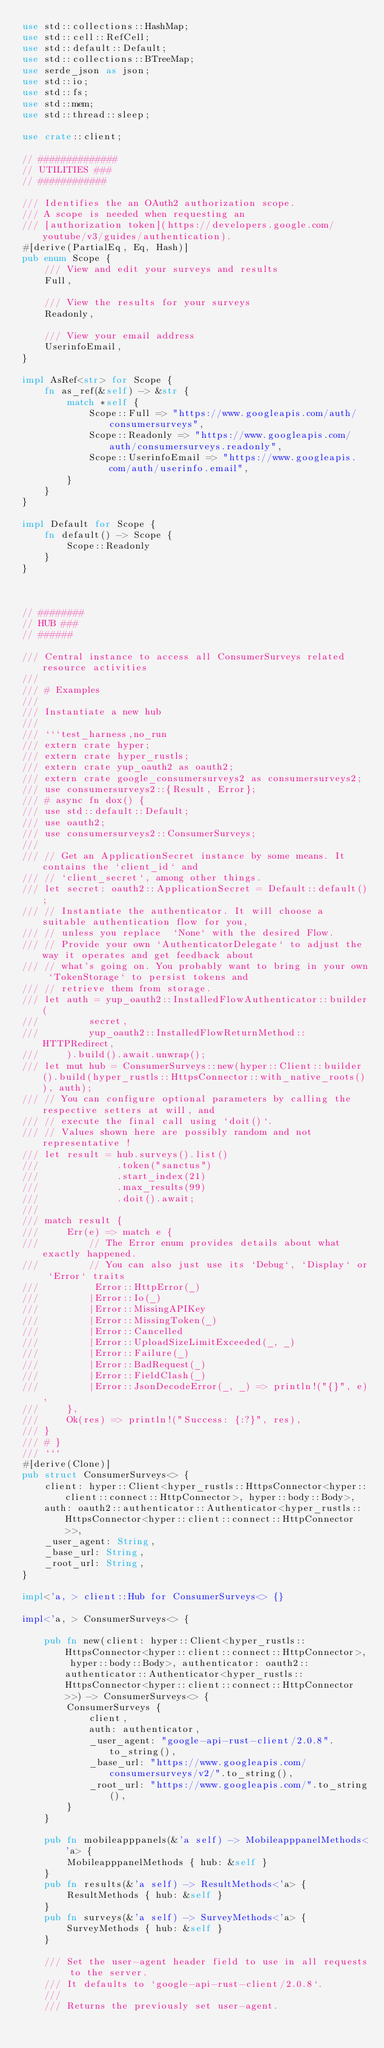<code> <loc_0><loc_0><loc_500><loc_500><_Rust_>use std::collections::HashMap;
use std::cell::RefCell;
use std::default::Default;
use std::collections::BTreeMap;
use serde_json as json;
use std::io;
use std::fs;
use std::mem;
use std::thread::sleep;

use crate::client;

// ##############
// UTILITIES ###
// ############

/// Identifies the an OAuth2 authorization scope.
/// A scope is needed when requesting an
/// [authorization token](https://developers.google.com/youtube/v3/guides/authentication).
#[derive(PartialEq, Eq, Hash)]
pub enum Scope {
    /// View and edit your surveys and results
    Full,

    /// View the results for your surveys
    Readonly,

    /// View your email address
    UserinfoEmail,
}

impl AsRef<str> for Scope {
    fn as_ref(&self) -> &str {
        match *self {
            Scope::Full => "https://www.googleapis.com/auth/consumersurveys",
            Scope::Readonly => "https://www.googleapis.com/auth/consumersurveys.readonly",
            Scope::UserinfoEmail => "https://www.googleapis.com/auth/userinfo.email",
        }
    }
}

impl Default for Scope {
    fn default() -> Scope {
        Scope::Readonly
    }
}



// ########
// HUB ###
// ######

/// Central instance to access all ConsumerSurveys related resource activities
///
/// # Examples
///
/// Instantiate a new hub
///
/// ```test_harness,no_run
/// extern crate hyper;
/// extern crate hyper_rustls;
/// extern crate yup_oauth2 as oauth2;
/// extern crate google_consumersurveys2 as consumersurveys2;
/// use consumersurveys2::{Result, Error};
/// # async fn dox() {
/// use std::default::Default;
/// use oauth2;
/// use consumersurveys2::ConsumerSurveys;
/// 
/// // Get an ApplicationSecret instance by some means. It contains the `client_id` and 
/// // `client_secret`, among other things.
/// let secret: oauth2::ApplicationSecret = Default::default();
/// // Instantiate the authenticator. It will choose a suitable authentication flow for you, 
/// // unless you replace  `None` with the desired Flow.
/// // Provide your own `AuthenticatorDelegate` to adjust the way it operates and get feedback about 
/// // what's going on. You probably want to bring in your own `TokenStorage` to persist tokens and
/// // retrieve them from storage.
/// let auth = yup_oauth2::InstalledFlowAuthenticator::builder(
///         secret,
///         yup_oauth2::InstalledFlowReturnMethod::HTTPRedirect,
///     ).build().await.unwrap();
/// let mut hub = ConsumerSurveys::new(hyper::Client::builder().build(hyper_rustls::HttpsConnector::with_native_roots()), auth);
/// // You can configure optional parameters by calling the respective setters at will, and
/// // execute the final call using `doit()`.
/// // Values shown here are possibly random and not representative !
/// let result = hub.surveys().list()
///              .token("sanctus")
///              .start_index(21)
///              .max_results(99)
///              .doit().await;
/// 
/// match result {
///     Err(e) => match e {
///         // The Error enum provides details about what exactly happened.
///         // You can also just use its `Debug`, `Display` or `Error` traits
///          Error::HttpError(_)
///         |Error::Io(_)
///         |Error::MissingAPIKey
///         |Error::MissingToken(_)
///         |Error::Cancelled
///         |Error::UploadSizeLimitExceeded(_, _)
///         |Error::Failure(_)
///         |Error::BadRequest(_)
///         |Error::FieldClash(_)
///         |Error::JsonDecodeError(_, _) => println!("{}", e),
///     },
///     Ok(res) => println!("Success: {:?}", res),
/// }
/// # }
/// ```
#[derive(Clone)]
pub struct ConsumerSurveys<> {
    client: hyper::Client<hyper_rustls::HttpsConnector<hyper::client::connect::HttpConnector>, hyper::body::Body>,
    auth: oauth2::authenticator::Authenticator<hyper_rustls::HttpsConnector<hyper::client::connect::HttpConnector>>,
    _user_agent: String,
    _base_url: String,
    _root_url: String,
}

impl<'a, > client::Hub for ConsumerSurveys<> {}

impl<'a, > ConsumerSurveys<> {

    pub fn new(client: hyper::Client<hyper_rustls::HttpsConnector<hyper::client::connect::HttpConnector>, hyper::body::Body>, authenticator: oauth2::authenticator::Authenticator<hyper_rustls::HttpsConnector<hyper::client::connect::HttpConnector>>) -> ConsumerSurveys<> {
        ConsumerSurveys {
            client,
            auth: authenticator,
            _user_agent: "google-api-rust-client/2.0.8".to_string(),
            _base_url: "https://www.googleapis.com/consumersurveys/v2/".to_string(),
            _root_url: "https://www.googleapis.com/".to_string(),
        }
    }

    pub fn mobileapppanels(&'a self) -> MobileapppanelMethods<'a> {
        MobileapppanelMethods { hub: &self }
    }
    pub fn results(&'a self) -> ResultMethods<'a> {
        ResultMethods { hub: &self }
    }
    pub fn surveys(&'a self) -> SurveyMethods<'a> {
        SurveyMethods { hub: &self }
    }

    /// Set the user-agent header field to use in all requests to the server.
    /// It defaults to `google-api-rust-client/2.0.8`.
    ///
    /// Returns the previously set user-agent.</code> 